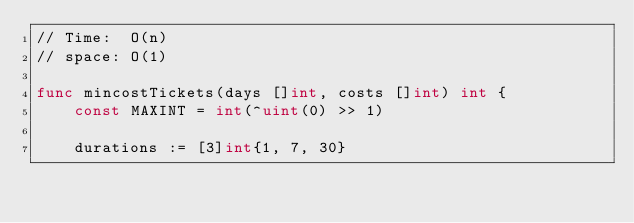<code> <loc_0><loc_0><loc_500><loc_500><_Go_>// Time:  O(n)
// space: O(1)

func mincostTickets(days []int, costs []int) int {
    const MAXINT = int(^uint(0) >> 1)

    durations := [3]int{1, 7, 30}</code> 